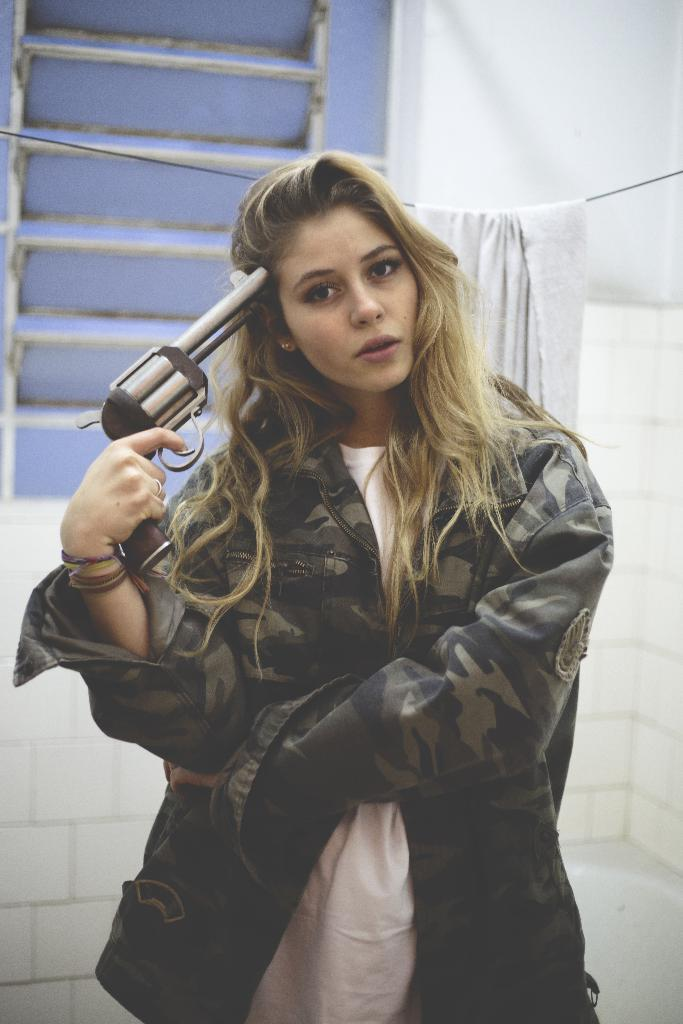Who is present in the image? There is a woman in the image. What is the woman holding in the image? The woman is holding a gun. What can be seen hanging in the background of the image? There is a cloth hanging on a wire in the background. What type of structure is visible in the background of the image? There is a wall visible in the background. What type of comb is the woman using to brush her silk dress in the image? There is no comb or silk dress present in the image. 